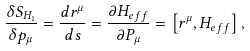Convert formula to latex. <formula><loc_0><loc_0><loc_500><loc_500>\frac { \delta S _ { H _ { 1 } } } { \delta p _ { \mu } } = \frac { d r ^ { \mu } } { d s } = \frac { \partial H _ { e f f } } { \partial P _ { \mu } } = \left [ r ^ { \mu } , H _ { e f f } \right ] ,</formula> 